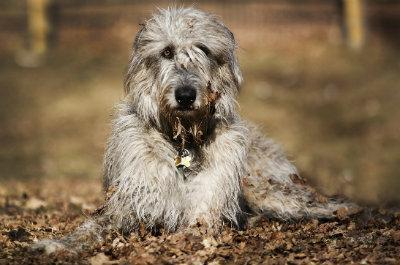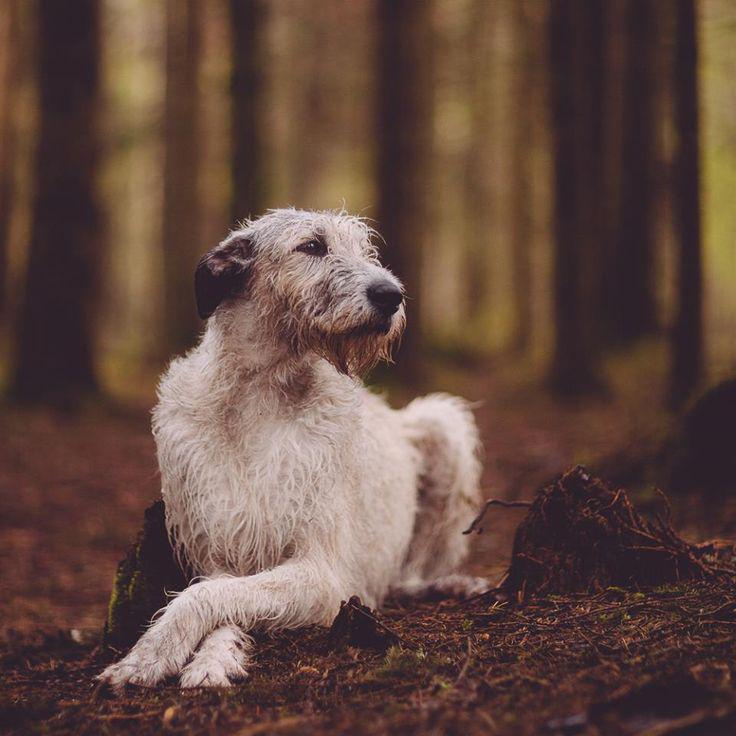The first image is the image on the left, the second image is the image on the right. Assess this claim about the two images: "Two dogs are laying down.". Correct or not? Answer yes or no. Yes. 